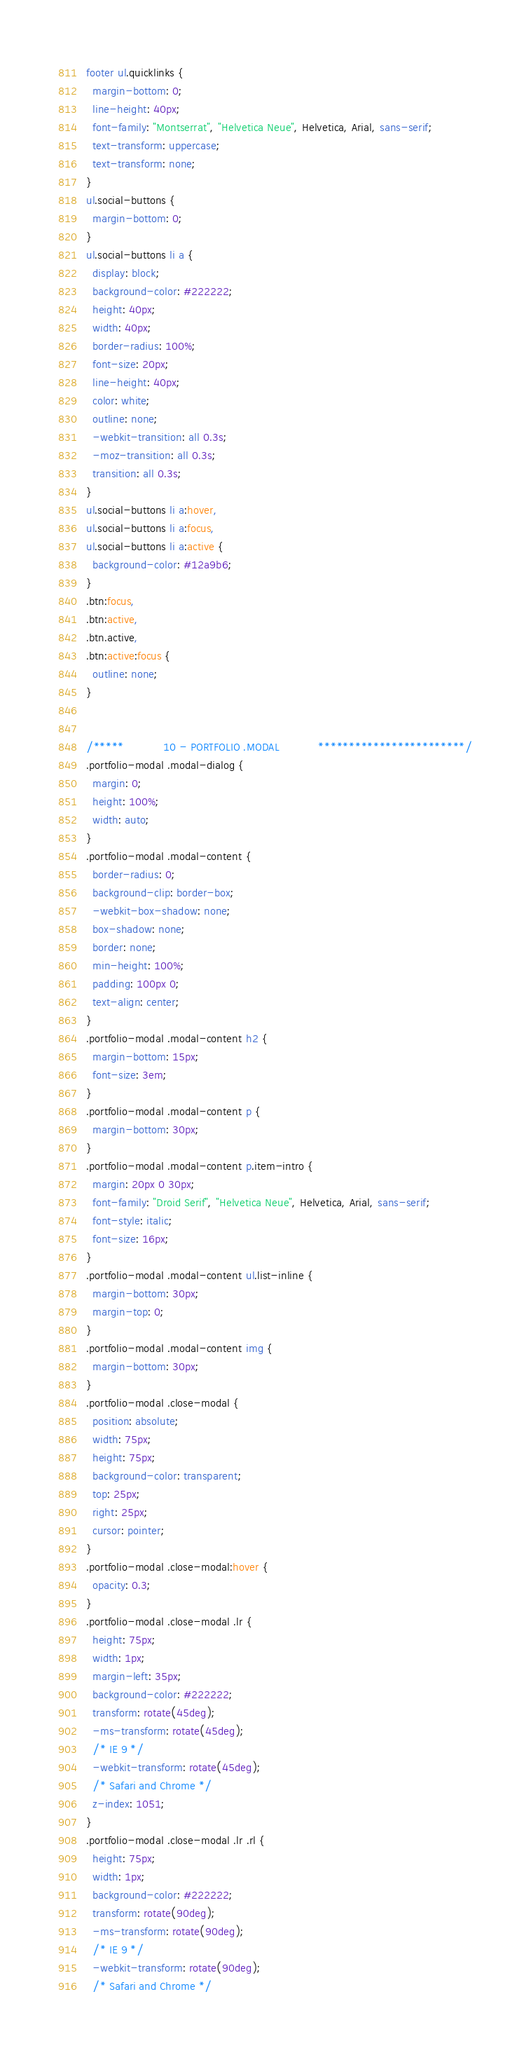<code> <loc_0><loc_0><loc_500><loc_500><_CSS_>footer ul.quicklinks {
  margin-bottom: 0;
  line-height: 40px;
  font-family: "Montserrat", "Helvetica Neue", Helvetica, Arial, sans-serif;
  text-transform: uppercase;
  text-transform: none;
}
ul.social-buttons {
  margin-bottom: 0;
}
ul.social-buttons li a {
  display: block;
  background-color: #222222;
  height: 40px;
  width: 40px;
  border-radius: 100%;
  font-size: 20px;
  line-height: 40px;
  color: white;
  outline: none;
  -webkit-transition: all 0.3s;
  -moz-transition: all 0.3s;
  transition: all 0.3s;
}
ul.social-buttons li a:hover,
ul.social-buttons li a:focus,
ul.social-buttons li a:active {
  background-color: #12a9b6;
}
.btn:focus,
.btn:active,
.btn.active,
.btn:active:focus {
  outline: none;
}


/*****            10 - PORTFOLIO .MODAL            ************************/
.portfolio-modal .modal-dialog {
  margin: 0;
  height: 100%;
  width: auto;
}
.portfolio-modal .modal-content {
  border-radius: 0;
  background-clip: border-box;
  -webkit-box-shadow: none;
  box-shadow: none;
  border: none;
  min-height: 100%;
  padding: 100px 0;
  text-align: center;
}
.portfolio-modal .modal-content h2 {
  margin-bottom: 15px;
  font-size: 3em;
}
.portfolio-modal .modal-content p {
  margin-bottom: 30px;
}
.portfolio-modal .modal-content p.item-intro {
  margin: 20px 0 30px;
  font-family: "Droid Serif", "Helvetica Neue", Helvetica, Arial, sans-serif;
  font-style: italic;
  font-size: 16px;
}
.portfolio-modal .modal-content ul.list-inline {
  margin-bottom: 30px;
  margin-top: 0;
}
.portfolio-modal .modal-content img {
  margin-bottom: 30px;
}
.portfolio-modal .close-modal {
  position: absolute;
  width: 75px;
  height: 75px;
  background-color: transparent;
  top: 25px;
  right: 25px;
  cursor: pointer;
}
.portfolio-modal .close-modal:hover {
  opacity: 0.3;
}
.portfolio-modal .close-modal .lr {
  height: 75px;
  width: 1px;
  margin-left: 35px;
  background-color: #222222;
  transform: rotate(45deg);
  -ms-transform: rotate(45deg);
  /* IE 9 */
  -webkit-transform: rotate(45deg);
  /* Safari and Chrome */
  z-index: 1051;
}
.portfolio-modal .close-modal .lr .rl {
  height: 75px;
  width: 1px;
  background-color: #222222;
  transform: rotate(90deg);
  -ms-transform: rotate(90deg);
  /* IE 9 */
  -webkit-transform: rotate(90deg);
  /* Safari and Chrome */</code> 